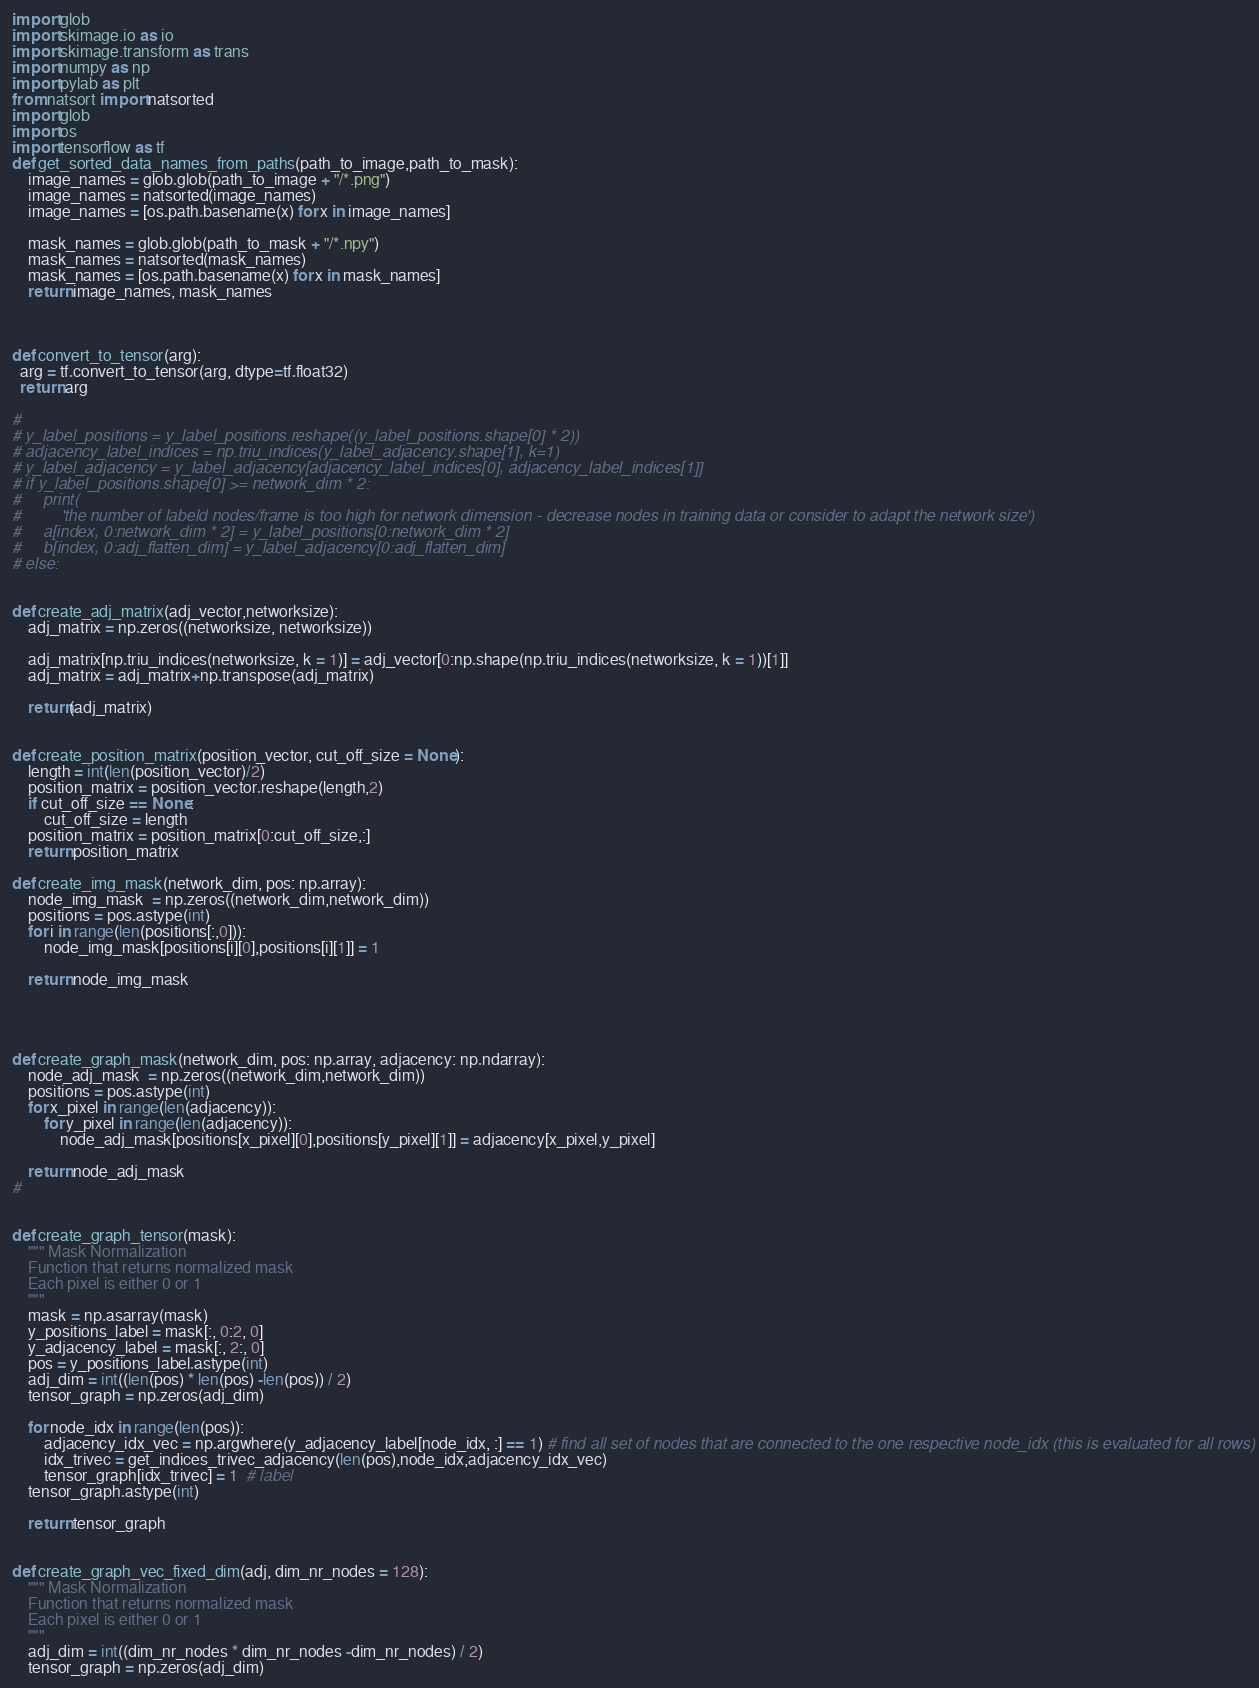<code> <loc_0><loc_0><loc_500><loc_500><_Python_>import glob
import skimage.io as io
import skimage.transform as trans
import numpy as np
import pylab as plt
from natsort import natsorted
import glob
import os
import tensorflow as tf
def get_sorted_data_names_from_paths(path_to_image,path_to_mask):
    image_names = glob.glob(path_to_image + "/*.png")
    image_names = natsorted(image_names)
    image_names = [os.path.basename(x) for x in image_names]

    mask_names = glob.glob(path_to_mask + "/*.npy")
    mask_names = natsorted(mask_names)
    mask_names = [os.path.basename(x) for x in mask_names]
    return image_names, mask_names



def convert_to_tensor(arg):
  arg = tf.convert_to_tensor(arg, dtype=tf.float32)
  return arg

#
# y_label_positions = y_label_positions.reshape((y_label_positions.shape[0] * 2))
# adjacency_label_indices = np.triu_indices(y_label_adjacency.shape[1], k=1)
# y_label_adjacency = y_label_adjacency[adjacency_label_indices[0], adjacency_label_indices[1]]
# if y_label_positions.shape[0] >= network_dim * 2:
#     print(
#         'the number of labeld nodes/frame is too high for network dimension - decrease nodes in training data or consider to adapt the network size')
#     a[index, 0:network_dim * 2] = y_label_positions[0:network_dim * 2]
#     b[index, 0:adj_flatten_dim] = y_label_adjacency[0:adj_flatten_dim]
# else:


def create_adj_matrix(adj_vector,networksize):
    adj_matrix = np.zeros((networksize, networksize))

    adj_matrix[np.triu_indices(networksize, k = 1)] = adj_vector[0:np.shape(np.triu_indices(networksize, k = 1))[1]]
    adj_matrix = adj_matrix+np.transpose(adj_matrix)

    return(adj_matrix)


def create_position_matrix(position_vector, cut_off_size = None):
    length = int(len(position_vector)/2)
    position_matrix = position_vector.reshape(length,2)
    if cut_off_size == None:
        cut_off_size = length
    position_matrix = position_matrix[0:cut_off_size,:]
    return position_matrix

def create_img_mask(network_dim, pos: np.array):
    node_img_mask  = np.zeros((network_dim,network_dim))
    positions = pos.astype(int)
    for i in range(len(positions[:,0])):
        node_img_mask[positions[i][0],positions[i][1]] = 1

    return node_img_mask




def create_graph_mask(network_dim, pos: np.array, adjacency: np.ndarray):
    node_adj_mask  = np.zeros((network_dim,network_dim))
    positions = pos.astype(int)
    for x_pixel in range(len(adjacency)):
        for y_pixel in range(len(adjacency)):
            node_adj_mask[positions[x_pixel][0],positions[y_pixel][1]] = adjacency[x_pixel,y_pixel]

    return node_adj_mask
#


def create_graph_tensor(mask):
    """ Mask Normalization
    Function that returns normalized mask
    Each pixel is either 0 or 1
    """
    mask = np.asarray(mask)
    y_positions_label = mask[:, 0:2, 0]
    y_adjacency_label = mask[:, 2:, 0]
    pos = y_positions_label.astype(int)
    adj_dim = int((len(pos) * len(pos) -len(pos)) / 2)
    tensor_graph = np.zeros(adj_dim)

    for node_idx in range(len(pos)):
        adjacency_idx_vec = np.argwhere(y_adjacency_label[node_idx, :] == 1) # find all set of nodes that are connected to the one respective node_idx (this is evaluated for all rows)
        idx_trivec = get_indices_trivec_adjacency(len(pos),node_idx,adjacency_idx_vec)
        tensor_graph[idx_trivec] = 1  # label
    tensor_graph.astype(int)

    return tensor_graph


def create_graph_vec_fixed_dim(adj, dim_nr_nodes = 128):
    """ Mask Normalization
    Function that returns normalized mask
    Each pixel is either 0 or 1
    """
    adj_dim = int((dim_nr_nodes * dim_nr_nodes -dim_nr_nodes) / 2)
    tensor_graph = np.zeros(adj_dim)</code> 